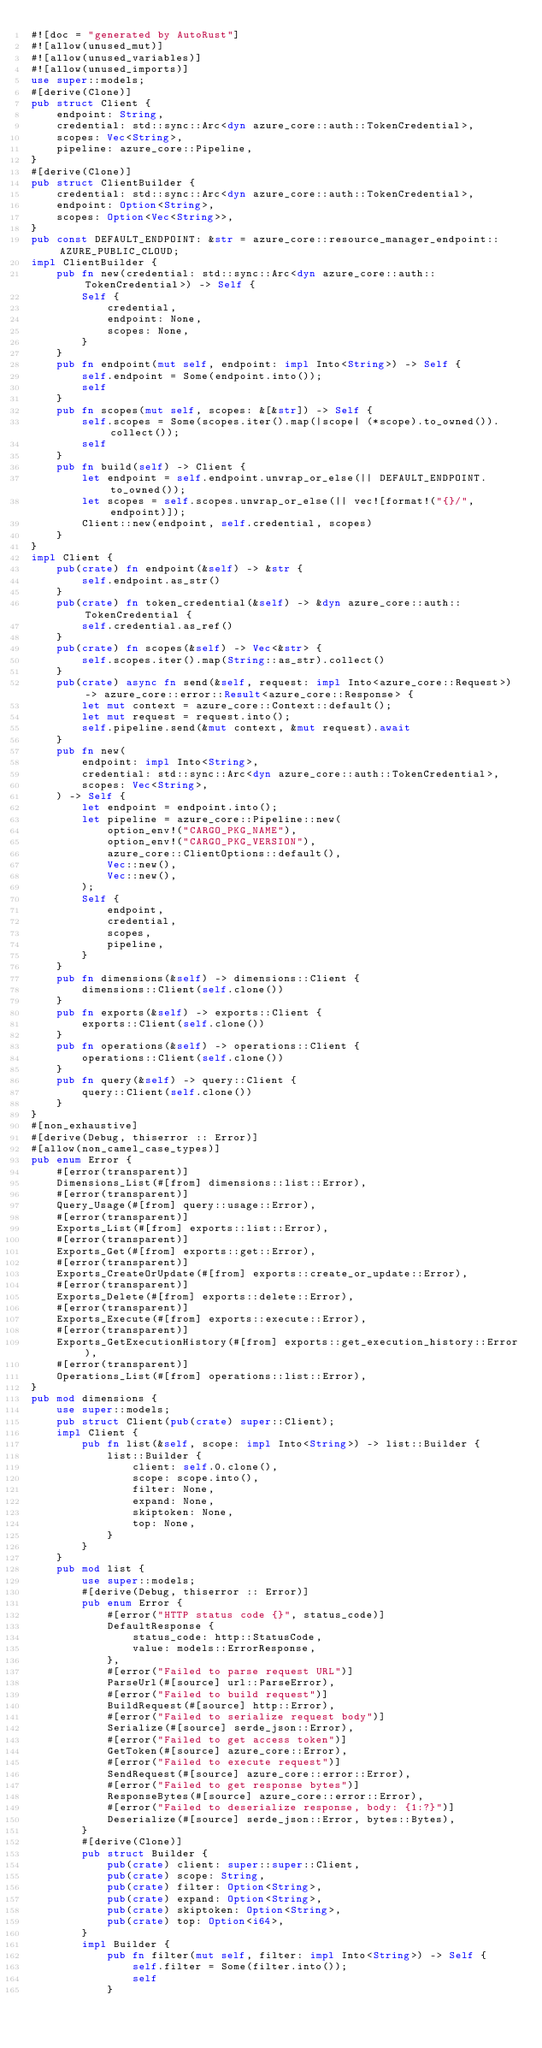<code> <loc_0><loc_0><loc_500><loc_500><_Rust_>#![doc = "generated by AutoRust"]
#![allow(unused_mut)]
#![allow(unused_variables)]
#![allow(unused_imports)]
use super::models;
#[derive(Clone)]
pub struct Client {
    endpoint: String,
    credential: std::sync::Arc<dyn azure_core::auth::TokenCredential>,
    scopes: Vec<String>,
    pipeline: azure_core::Pipeline,
}
#[derive(Clone)]
pub struct ClientBuilder {
    credential: std::sync::Arc<dyn azure_core::auth::TokenCredential>,
    endpoint: Option<String>,
    scopes: Option<Vec<String>>,
}
pub const DEFAULT_ENDPOINT: &str = azure_core::resource_manager_endpoint::AZURE_PUBLIC_CLOUD;
impl ClientBuilder {
    pub fn new(credential: std::sync::Arc<dyn azure_core::auth::TokenCredential>) -> Self {
        Self {
            credential,
            endpoint: None,
            scopes: None,
        }
    }
    pub fn endpoint(mut self, endpoint: impl Into<String>) -> Self {
        self.endpoint = Some(endpoint.into());
        self
    }
    pub fn scopes(mut self, scopes: &[&str]) -> Self {
        self.scopes = Some(scopes.iter().map(|scope| (*scope).to_owned()).collect());
        self
    }
    pub fn build(self) -> Client {
        let endpoint = self.endpoint.unwrap_or_else(|| DEFAULT_ENDPOINT.to_owned());
        let scopes = self.scopes.unwrap_or_else(|| vec![format!("{}/", endpoint)]);
        Client::new(endpoint, self.credential, scopes)
    }
}
impl Client {
    pub(crate) fn endpoint(&self) -> &str {
        self.endpoint.as_str()
    }
    pub(crate) fn token_credential(&self) -> &dyn azure_core::auth::TokenCredential {
        self.credential.as_ref()
    }
    pub(crate) fn scopes(&self) -> Vec<&str> {
        self.scopes.iter().map(String::as_str).collect()
    }
    pub(crate) async fn send(&self, request: impl Into<azure_core::Request>) -> azure_core::error::Result<azure_core::Response> {
        let mut context = azure_core::Context::default();
        let mut request = request.into();
        self.pipeline.send(&mut context, &mut request).await
    }
    pub fn new(
        endpoint: impl Into<String>,
        credential: std::sync::Arc<dyn azure_core::auth::TokenCredential>,
        scopes: Vec<String>,
    ) -> Self {
        let endpoint = endpoint.into();
        let pipeline = azure_core::Pipeline::new(
            option_env!("CARGO_PKG_NAME"),
            option_env!("CARGO_PKG_VERSION"),
            azure_core::ClientOptions::default(),
            Vec::new(),
            Vec::new(),
        );
        Self {
            endpoint,
            credential,
            scopes,
            pipeline,
        }
    }
    pub fn dimensions(&self) -> dimensions::Client {
        dimensions::Client(self.clone())
    }
    pub fn exports(&self) -> exports::Client {
        exports::Client(self.clone())
    }
    pub fn operations(&self) -> operations::Client {
        operations::Client(self.clone())
    }
    pub fn query(&self) -> query::Client {
        query::Client(self.clone())
    }
}
#[non_exhaustive]
#[derive(Debug, thiserror :: Error)]
#[allow(non_camel_case_types)]
pub enum Error {
    #[error(transparent)]
    Dimensions_List(#[from] dimensions::list::Error),
    #[error(transparent)]
    Query_Usage(#[from] query::usage::Error),
    #[error(transparent)]
    Exports_List(#[from] exports::list::Error),
    #[error(transparent)]
    Exports_Get(#[from] exports::get::Error),
    #[error(transparent)]
    Exports_CreateOrUpdate(#[from] exports::create_or_update::Error),
    #[error(transparent)]
    Exports_Delete(#[from] exports::delete::Error),
    #[error(transparent)]
    Exports_Execute(#[from] exports::execute::Error),
    #[error(transparent)]
    Exports_GetExecutionHistory(#[from] exports::get_execution_history::Error),
    #[error(transparent)]
    Operations_List(#[from] operations::list::Error),
}
pub mod dimensions {
    use super::models;
    pub struct Client(pub(crate) super::Client);
    impl Client {
        pub fn list(&self, scope: impl Into<String>) -> list::Builder {
            list::Builder {
                client: self.0.clone(),
                scope: scope.into(),
                filter: None,
                expand: None,
                skiptoken: None,
                top: None,
            }
        }
    }
    pub mod list {
        use super::models;
        #[derive(Debug, thiserror :: Error)]
        pub enum Error {
            #[error("HTTP status code {}", status_code)]
            DefaultResponse {
                status_code: http::StatusCode,
                value: models::ErrorResponse,
            },
            #[error("Failed to parse request URL")]
            ParseUrl(#[source] url::ParseError),
            #[error("Failed to build request")]
            BuildRequest(#[source] http::Error),
            #[error("Failed to serialize request body")]
            Serialize(#[source] serde_json::Error),
            #[error("Failed to get access token")]
            GetToken(#[source] azure_core::Error),
            #[error("Failed to execute request")]
            SendRequest(#[source] azure_core::error::Error),
            #[error("Failed to get response bytes")]
            ResponseBytes(#[source] azure_core::error::Error),
            #[error("Failed to deserialize response, body: {1:?}")]
            Deserialize(#[source] serde_json::Error, bytes::Bytes),
        }
        #[derive(Clone)]
        pub struct Builder {
            pub(crate) client: super::super::Client,
            pub(crate) scope: String,
            pub(crate) filter: Option<String>,
            pub(crate) expand: Option<String>,
            pub(crate) skiptoken: Option<String>,
            pub(crate) top: Option<i64>,
        }
        impl Builder {
            pub fn filter(mut self, filter: impl Into<String>) -> Self {
                self.filter = Some(filter.into());
                self
            }</code> 